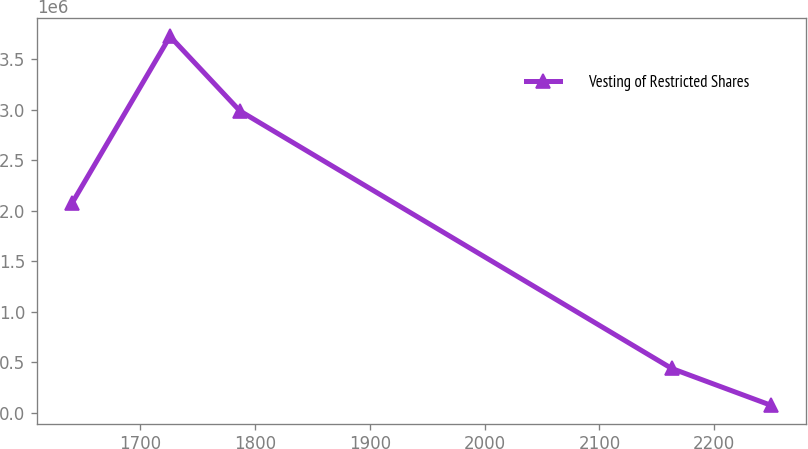Convert chart. <chart><loc_0><loc_0><loc_500><loc_500><line_chart><ecel><fcel>Vesting of Restricted Shares<nl><fcel>1640.28<fcel>2.07389e+06<nl><fcel>1725.75<fcel>3.72644e+06<nl><fcel>1786.68<fcel>2.98912e+06<nl><fcel>2162.95<fcel>440843<nl><fcel>2249.62<fcel>75776.3<nl></chart> 